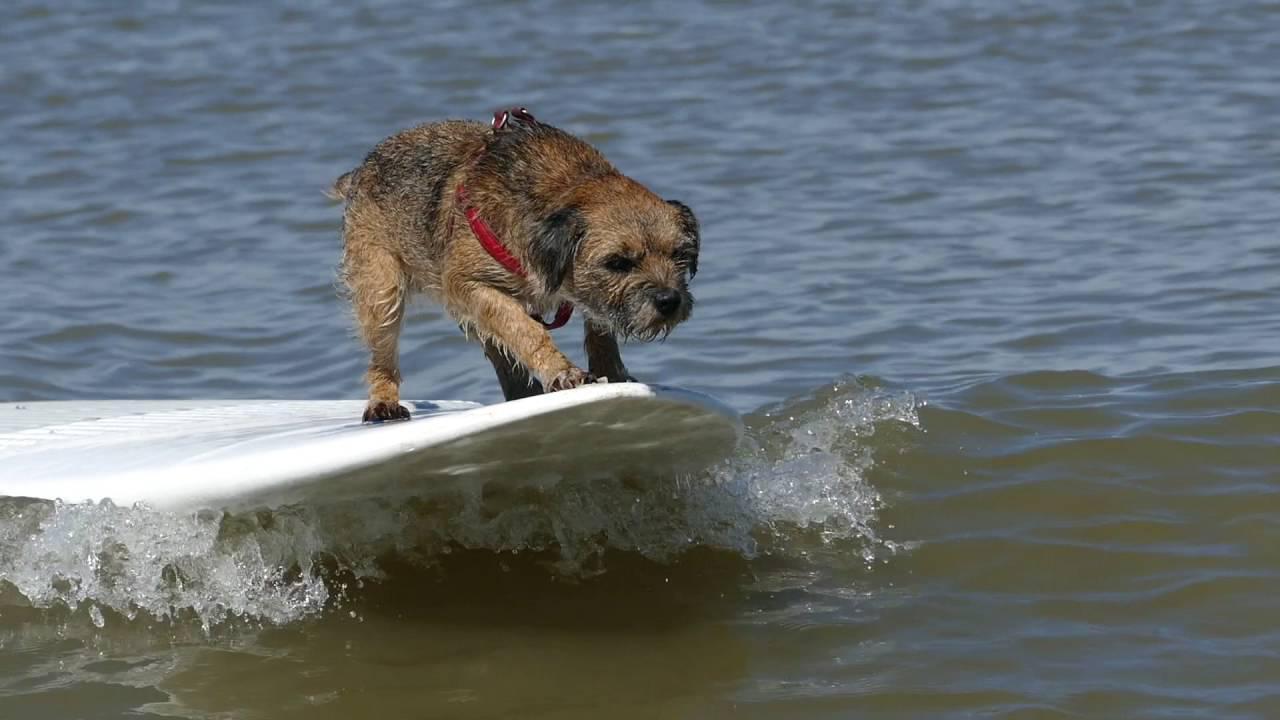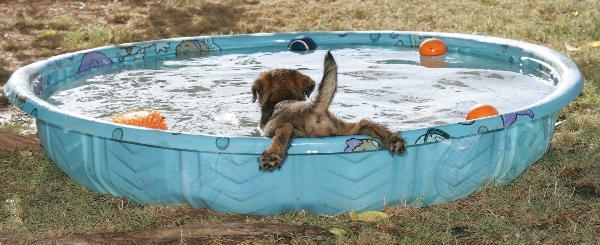The first image is the image on the left, the second image is the image on the right. Considering the images on both sides, is "There is a human in the water with at least one dog in the picture on the left." valid? Answer yes or no. No. The first image is the image on the left, the second image is the image on the right. Assess this claim about the two images: "A dog is in the water with a man.". Correct or not? Answer yes or no. No. 